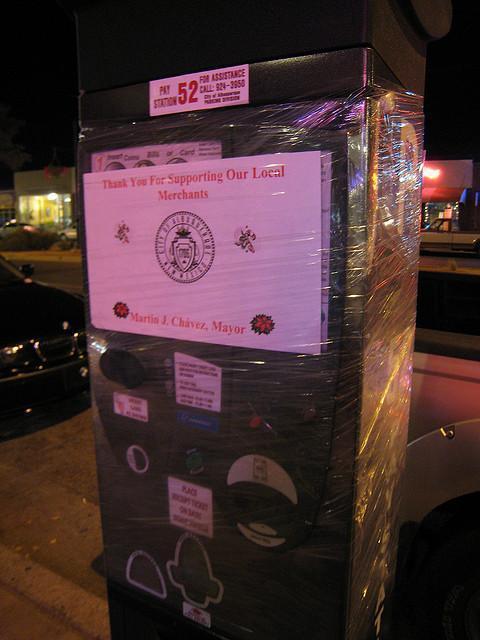This machine is meant to assist what type people in payments?
Answer the question by selecting the correct answer among the 4 following choices.
Options: Bikers, motorists, unicyclists, prisoners. Motorists. 